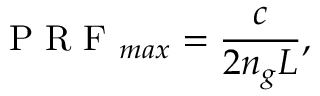<formula> <loc_0><loc_0><loc_500><loc_500>P R F _ { \max } = \frac { c } { 2 n _ { g } L } ,</formula> 